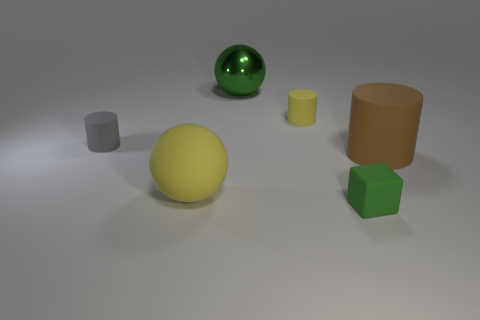Add 2 brown metal cubes. How many objects exist? 8 Subtract all spheres. How many objects are left? 4 Add 1 big brown matte cylinders. How many big brown matte cylinders exist? 2 Subtract 0 cyan spheres. How many objects are left? 6 Subtract all big objects. Subtract all tiny blocks. How many objects are left? 2 Add 3 green shiny balls. How many green shiny balls are left? 4 